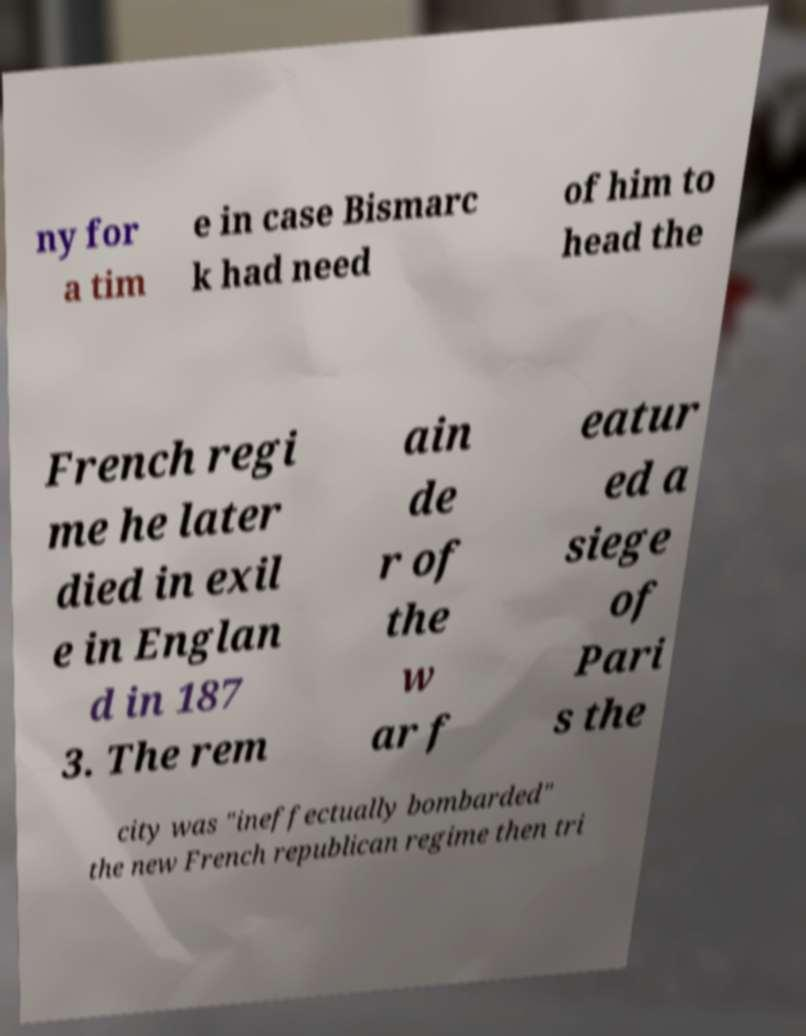What messages or text are displayed in this image? I need them in a readable, typed format. ny for a tim e in case Bismarc k had need of him to head the French regi me he later died in exil e in Englan d in 187 3. The rem ain de r of the w ar f eatur ed a siege of Pari s the city was "ineffectually bombarded" the new French republican regime then tri 